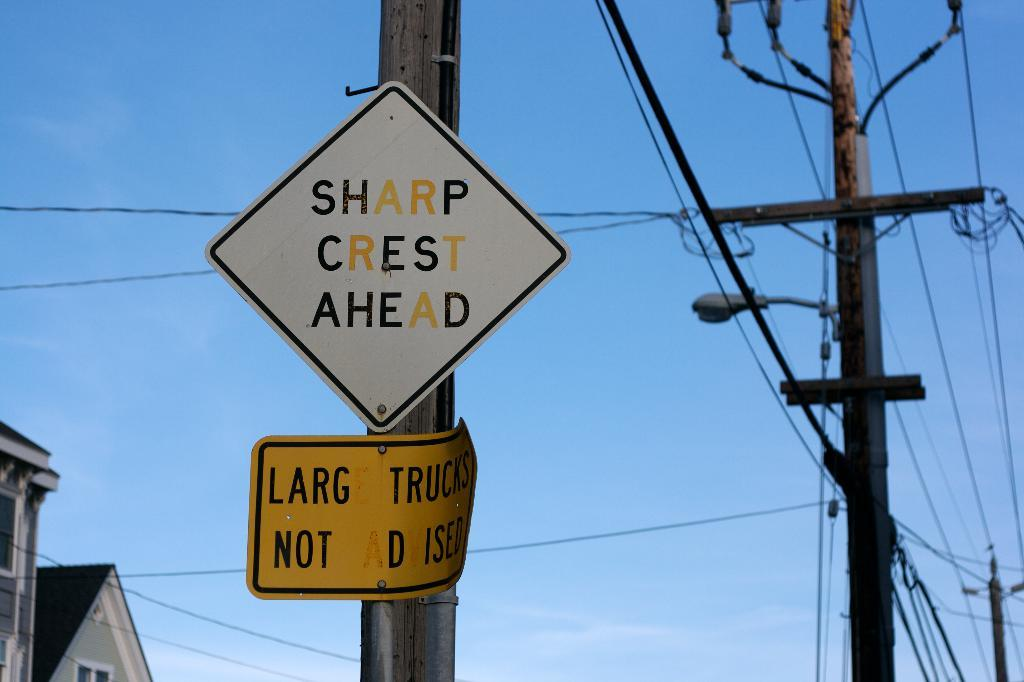<image>
Offer a succinct explanation of the picture presented. White sign on a pole which says "Sharp Crest Ahead". 